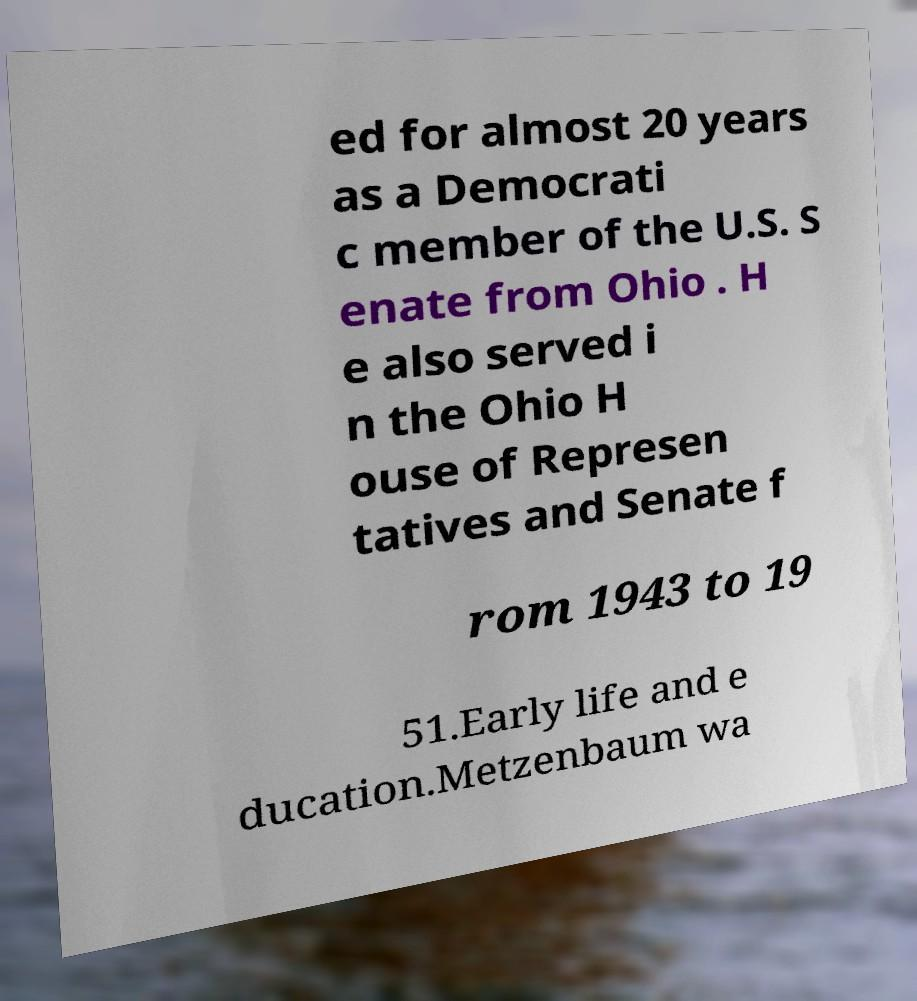Could you assist in decoding the text presented in this image and type it out clearly? ed for almost 20 years as a Democrati c member of the U.S. S enate from Ohio . H e also served i n the Ohio H ouse of Represen tatives and Senate f rom 1943 to 19 51.Early life and e ducation.Metzenbaum wa 